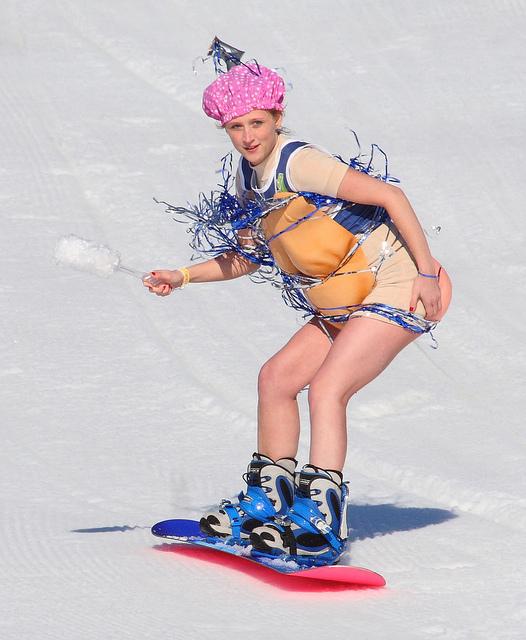What is the girl wearing on her head?
Short answer required. Hat. Is this an appropriate outfit for a snowy day?
Short answer required. No. Is the snow deep?
Write a very short answer. Yes. 